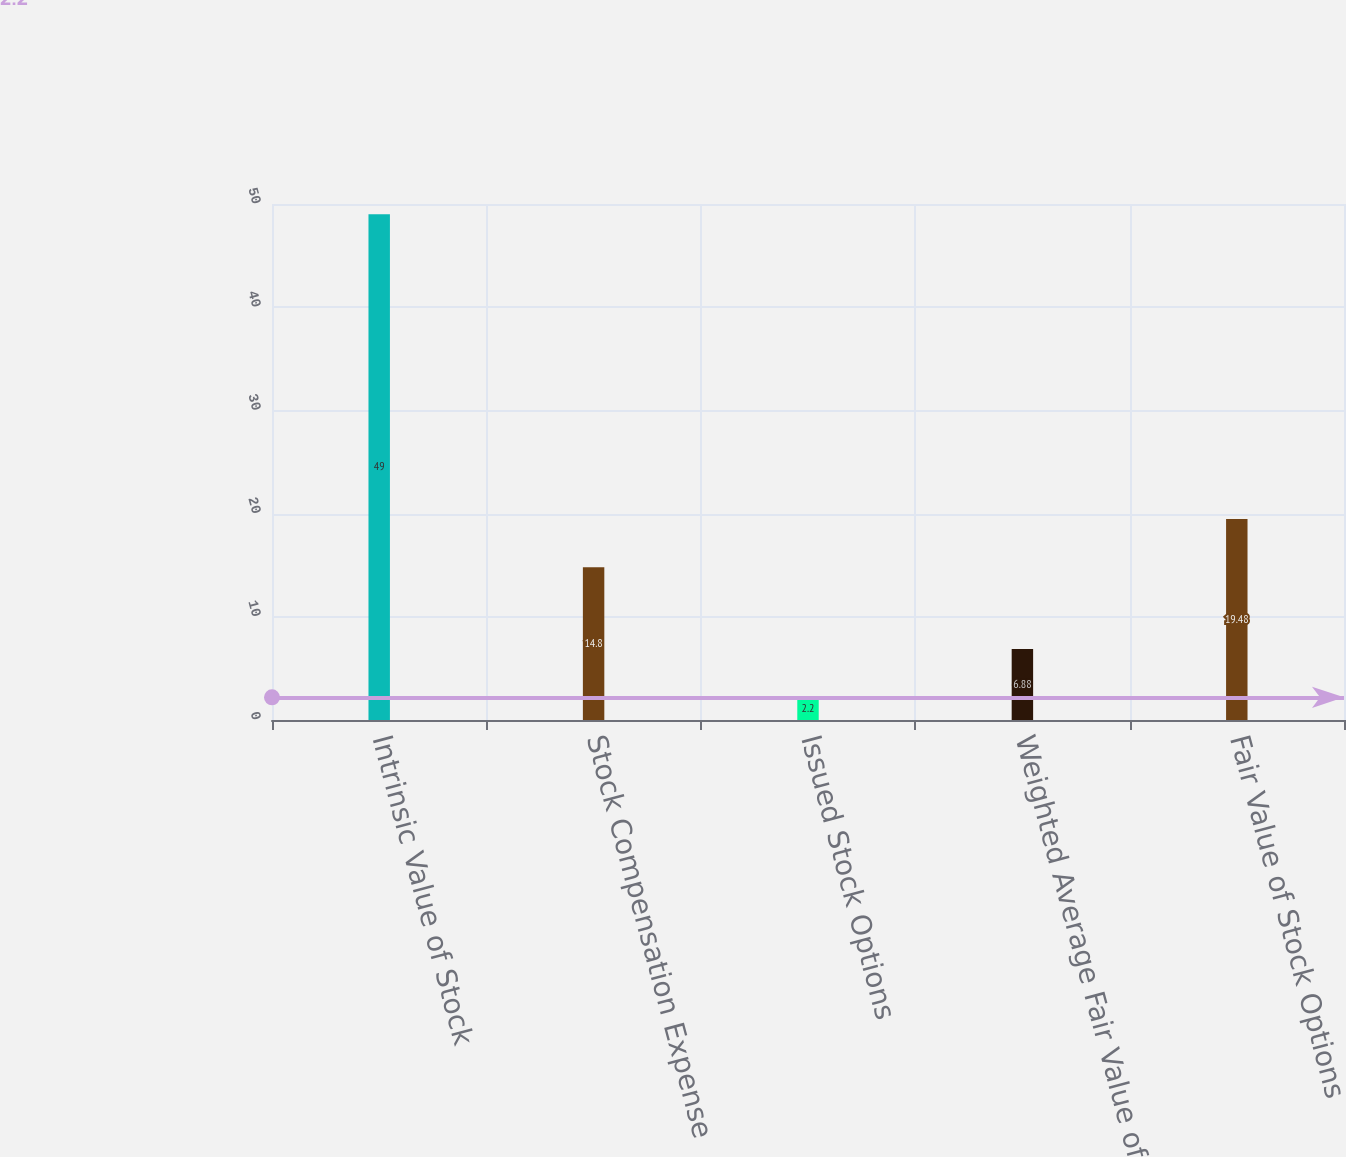Convert chart. <chart><loc_0><loc_0><loc_500><loc_500><bar_chart><fcel>Intrinsic Value of Stock<fcel>Stock Compensation Expense<fcel>Issued Stock Options<fcel>Weighted Average Fair Value of<fcel>Fair Value of Stock Options<nl><fcel>49<fcel>14.8<fcel>2.2<fcel>6.88<fcel>19.48<nl></chart> 